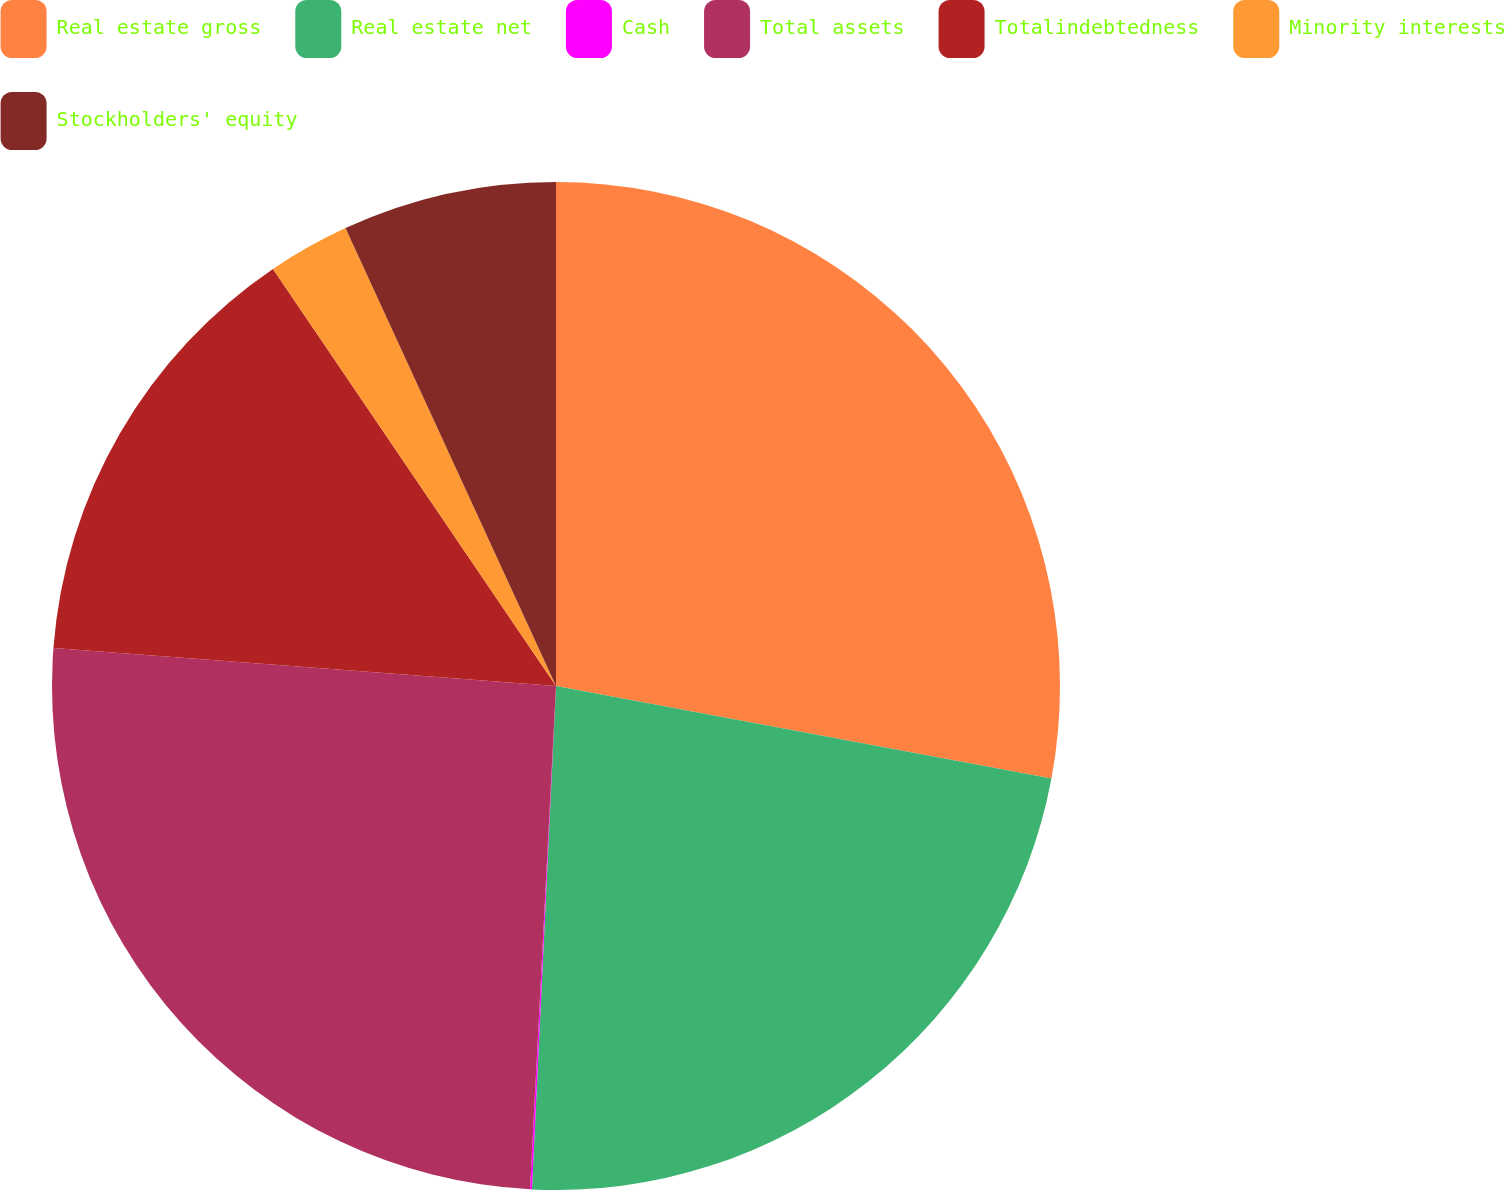Convert chart to OTSL. <chart><loc_0><loc_0><loc_500><loc_500><pie_chart><fcel>Real estate gross<fcel>Real estate net<fcel>Cash<fcel>Total assets<fcel>Totalindebtedness<fcel>Minority interests<fcel>Stockholders' equity<nl><fcel>27.94%<fcel>22.82%<fcel>0.06%<fcel>25.38%<fcel>14.31%<fcel>2.63%<fcel>6.86%<nl></chart> 